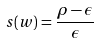Convert formula to latex. <formula><loc_0><loc_0><loc_500><loc_500>s ( w ) = \frac { \rho - \epsilon } { \epsilon }</formula> 